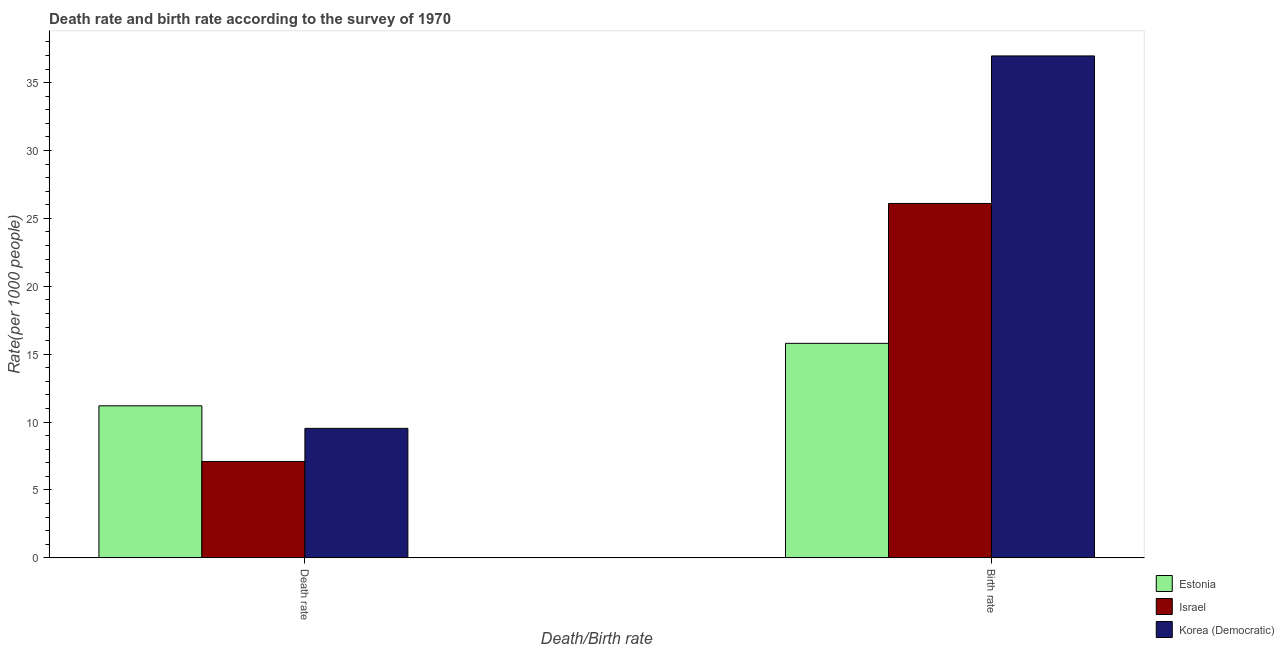How many different coloured bars are there?
Provide a short and direct response. 3. How many groups of bars are there?
Your response must be concise. 2. Are the number of bars per tick equal to the number of legend labels?
Offer a very short reply. Yes. Are the number of bars on each tick of the X-axis equal?
Your answer should be very brief. Yes. How many bars are there on the 2nd tick from the right?
Ensure brevity in your answer.  3. What is the label of the 1st group of bars from the left?
Your answer should be very brief. Death rate. What is the death rate in Israel?
Make the answer very short. 7.1. Across all countries, what is the maximum birth rate?
Give a very brief answer. 36.96. In which country was the birth rate maximum?
Your answer should be very brief. Korea (Democratic). In which country was the death rate minimum?
Your answer should be compact. Israel. What is the total birth rate in the graph?
Provide a succinct answer. 78.86. What is the difference between the death rate in Korea (Democratic) and that in Estonia?
Provide a short and direct response. -1.66. What is the difference between the birth rate in Estonia and the death rate in Korea (Democratic)?
Offer a very short reply. 6.26. What is the average birth rate per country?
Make the answer very short. 26.29. What is the difference between the birth rate and death rate in Korea (Democratic)?
Keep it short and to the point. 27.43. In how many countries, is the birth rate greater than 22 ?
Ensure brevity in your answer.  2. What is the ratio of the death rate in Israel to that in Estonia?
Keep it short and to the point. 0.63. What does the 2nd bar from the left in Death rate represents?
Keep it short and to the point. Israel. What does the 1st bar from the right in Birth rate represents?
Make the answer very short. Korea (Democratic). How many countries are there in the graph?
Provide a succinct answer. 3. What is the difference between two consecutive major ticks on the Y-axis?
Provide a short and direct response. 5. Does the graph contain any zero values?
Your response must be concise. No. Does the graph contain grids?
Provide a short and direct response. No. What is the title of the graph?
Keep it short and to the point. Death rate and birth rate according to the survey of 1970. What is the label or title of the X-axis?
Your answer should be very brief. Death/Birth rate. What is the label or title of the Y-axis?
Offer a very short reply. Rate(per 1000 people). What is the Rate(per 1000 people) of Korea (Democratic) in Death rate?
Ensure brevity in your answer.  9.54. What is the Rate(per 1000 people) of Estonia in Birth rate?
Provide a short and direct response. 15.8. What is the Rate(per 1000 people) of Israel in Birth rate?
Offer a terse response. 26.1. What is the Rate(per 1000 people) in Korea (Democratic) in Birth rate?
Make the answer very short. 36.96. Across all Death/Birth rate, what is the maximum Rate(per 1000 people) of Estonia?
Offer a terse response. 15.8. Across all Death/Birth rate, what is the maximum Rate(per 1000 people) in Israel?
Your response must be concise. 26.1. Across all Death/Birth rate, what is the maximum Rate(per 1000 people) in Korea (Democratic)?
Keep it short and to the point. 36.96. Across all Death/Birth rate, what is the minimum Rate(per 1000 people) in Estonia?
Make the answer very short. 11.2. Across all Death/Birth rate, what is the minimum Rate(per 1000 people) in Israel?
Ensure brevity in your answer.  7.1. Across all Death/Birth rate, what is the minimum Rate(per 1000 people) of Korea (Democratic)?
Make the answer very short. 9.54. What is the total Rate(per 1000 people) of Estonia in the graph?
Your answer should be very brief. 27. What is the total Rate(per 1000 people) in Israel in the graph?
Your response must be concise. 33.2. What is the total Rate(per 1000 people) in Korea (Democratic) in the graph?
Make the answer very short. 46.5. What is the difference between the Rate(per 1000 people) of Estonia in Death rate and that in Birth rate?
Your answer should be very brief. -4.6. What is the difference between the Rate(per 1000 people) of Korea (Democratic) in Death rate and that in Birth rate?
Make the answer very short. -27.43. What is the difference between the Rate(per 1000 people) of Estonia in Death rate and the Rate(per 1000 people) of Israel in Birth rate?
Your answer should be very brief. -14.9. What is the difference between the Rate(per 1000 people) of Estonia in Death rate and the Rate(per 1000 people) of Korea (Democratic) in Birth rate?
Your answer should be very brief. -25.76. What is the difference between the Rate(per 1000 people) in Israel in Death rate and the Rate(per 1000 people) in Korea (Democratic) in Birth rate?
Your answer should be compact. -29.86. What is the average Rate(per 1000 people) in Estonia per Death/Birth rate?
Keep it short and to the point. 13.5. What is the average Rate(per 1000 people) in Korea (Democratic) per Death/Birth rate?
Provide a short and direct response. 23.25. What is the difference between the Rate(per 1000 people) in Estonia and Rate(per 1000 people) in Korea (Democratic) in Death rate?
Make the answer very short. 1.66. What is the difference between the Rate(per 1000 people) in Israel and Rate(per 1000 people) in Korea (Democratic) in Death rate?
Provide a succinct answer. -2.44. What is the difference between the Rate(per 1000 people) of Estonia and Rate(per 1000 people) of Israel in Birth rate?
Your response must be concise. -10.3. What is the difference between the Rate(per 1000 people) in Estonia and Rate(per 1000 people) in Korea (Democratic) in Birth rate?
Make the answer very short. -21.16. What is the difference between the Rate(per 1000 people) in Israel and Rate(per 1000 people) in Korea (Democratic) in Birth rate?
Your response must be concise. -10.86. What is the ratio of the Rate(per 1000 people) in Estonia in Death rate to that in Birth rate?
Offer a very short reply. 0.71. What is the ratio of the Rate(per 1000 people) of Israel in Death rate to that in Birth rate?
Make the answer very short. 0.27. What is the ratio of the Rate(per 1000 people) in Korea (Democratic) in Death rate to that in Birth rate?
Your answer should be compact. 0.26. What is the difference between the highest and the second highest Rate(per 1000 people) of Korea (Democratic)?
Your response must be concise. 27.43. What is the difference between the highest and the lowest Rate(per 1000 people) in Estonia?
Keep it short and to the point. 4.6. What is the difference between the highest and the lowest Rate(per 1000 people) of Korea (Democratic)?
Your response must be concise. 27.43. 